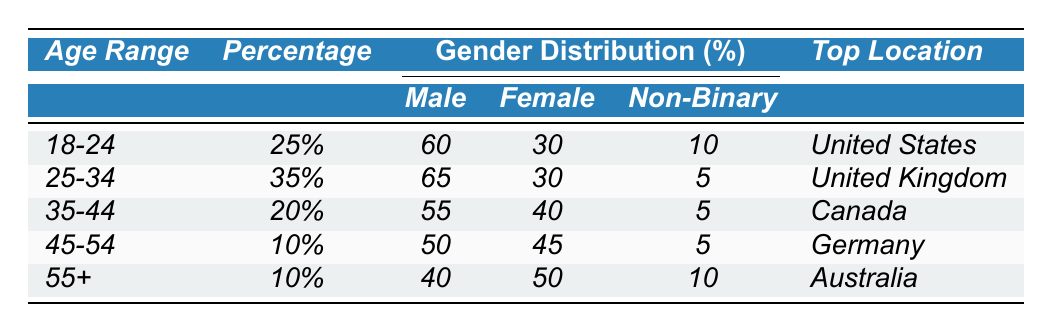What is the percentage of NFT buyers aged 25-34? According to the table, the percentage of NFT buyers in the age range 25-34 is listed directly under the "Percentage" column for that age range. It shows 35%.
Answer: 35% Which age range has the highest percentage of NFT buyers? By examining the "Percentage" column, the highest percentage is found in the age range 25-34, which shows 35%.
Answer: 25-34 What percentage of female NFT buyers are in the age range of 45-54? The "Gender Distribution" section specifically for females in the age range 45-54 shows 45%.
Answer: 45% Is it true that the majority of NFT buyers aged 35-44 are male? The table indicates that 55% of NFT buyers aged 35-44 are male, which is indeed the majority (over 50%).
Answer: Yes What is the combined percentage of NFT buyers that are 35 and older? To find this, we add the percentages of age ranges 35-44, 45-54, and 55+, which are 20%, 10%, and 10%, respectively. So, 20 + 10 + 10 = 40%.
Answer: 40% How many more male NFT buyers than non-binary buyers are there in the 18-24 age range? In the 18-24 age range, there are 60% male buyers and 10% non-binary buyers. To find the difference, we subtract 10 from 60, which gives us 50%.
Answer: 50% What is the most common location for NFT buyers aged 55 and older? The table indicates that the top location for NFT buyers aged 55 and older (55+) is Australia, listed in the "Top Location" section.
Answer: Australia If we consider the top two age ranges, what is the average percentage of NFT buyers in those categories? The top two age ranges are 18-24 (25%) and 25-34 (35%). To find the average, we add these percentages (25 + 35) = 60%, then divide by 2 to get 30%.
Answer: 30% Which gender has the least representation in the 25-34 age range among NFT buyers? The table shows that for the 25-34 age range, the gender with the least representation is non-binary, which is only 5%.
Answer: Non-binary How does the percentage of female NFT buyers change from the age range 18-24 to 35-44? The percentage of female buyers in the 18-24 age range is 30%, while in the 35-44 age range it is 40%. The change is an increase of 10%.
Answer: Increase of 10% 